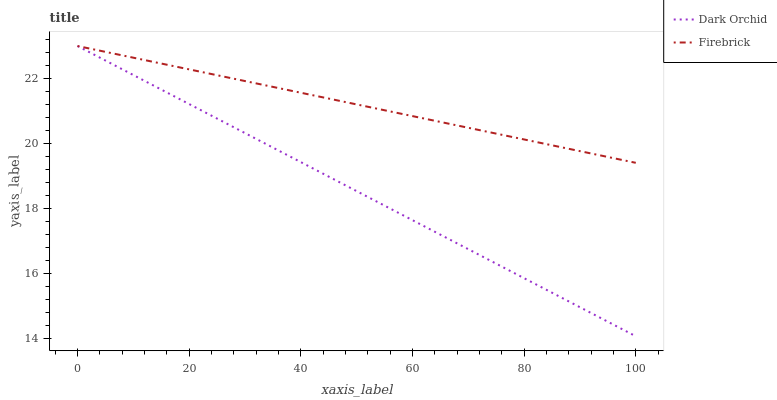Does Dark Orchid have the minimum area under the curve?
Answer yes or no. Yes. Does Firebrick have the maximum area under the curve?
Answer yes or no. Yes. Does Dark Orchid have the maximum area under the curve?
Answer yes or no. No. Is Firebrick the smoothest?
Answer yes or no. Yes. Is Dark Orchid the roughest?
Answer yes or no. Yes. Is Dark Orchid the smoothest?
Answer yes or no. No. Does Dark Orchid have the lowest value?
Answer yes or no. Yes. Does Dark Orchid have the highest value?
Answer yes or no. Yes. Does Dark Orchid intersect Firebrick?
Answer yes or no. Yes. Is Dark Orchid less than Firebrick?
Answer yes or no. No. Is Dark Orchid greater than Firebrick?
Answer yes or no. No. 